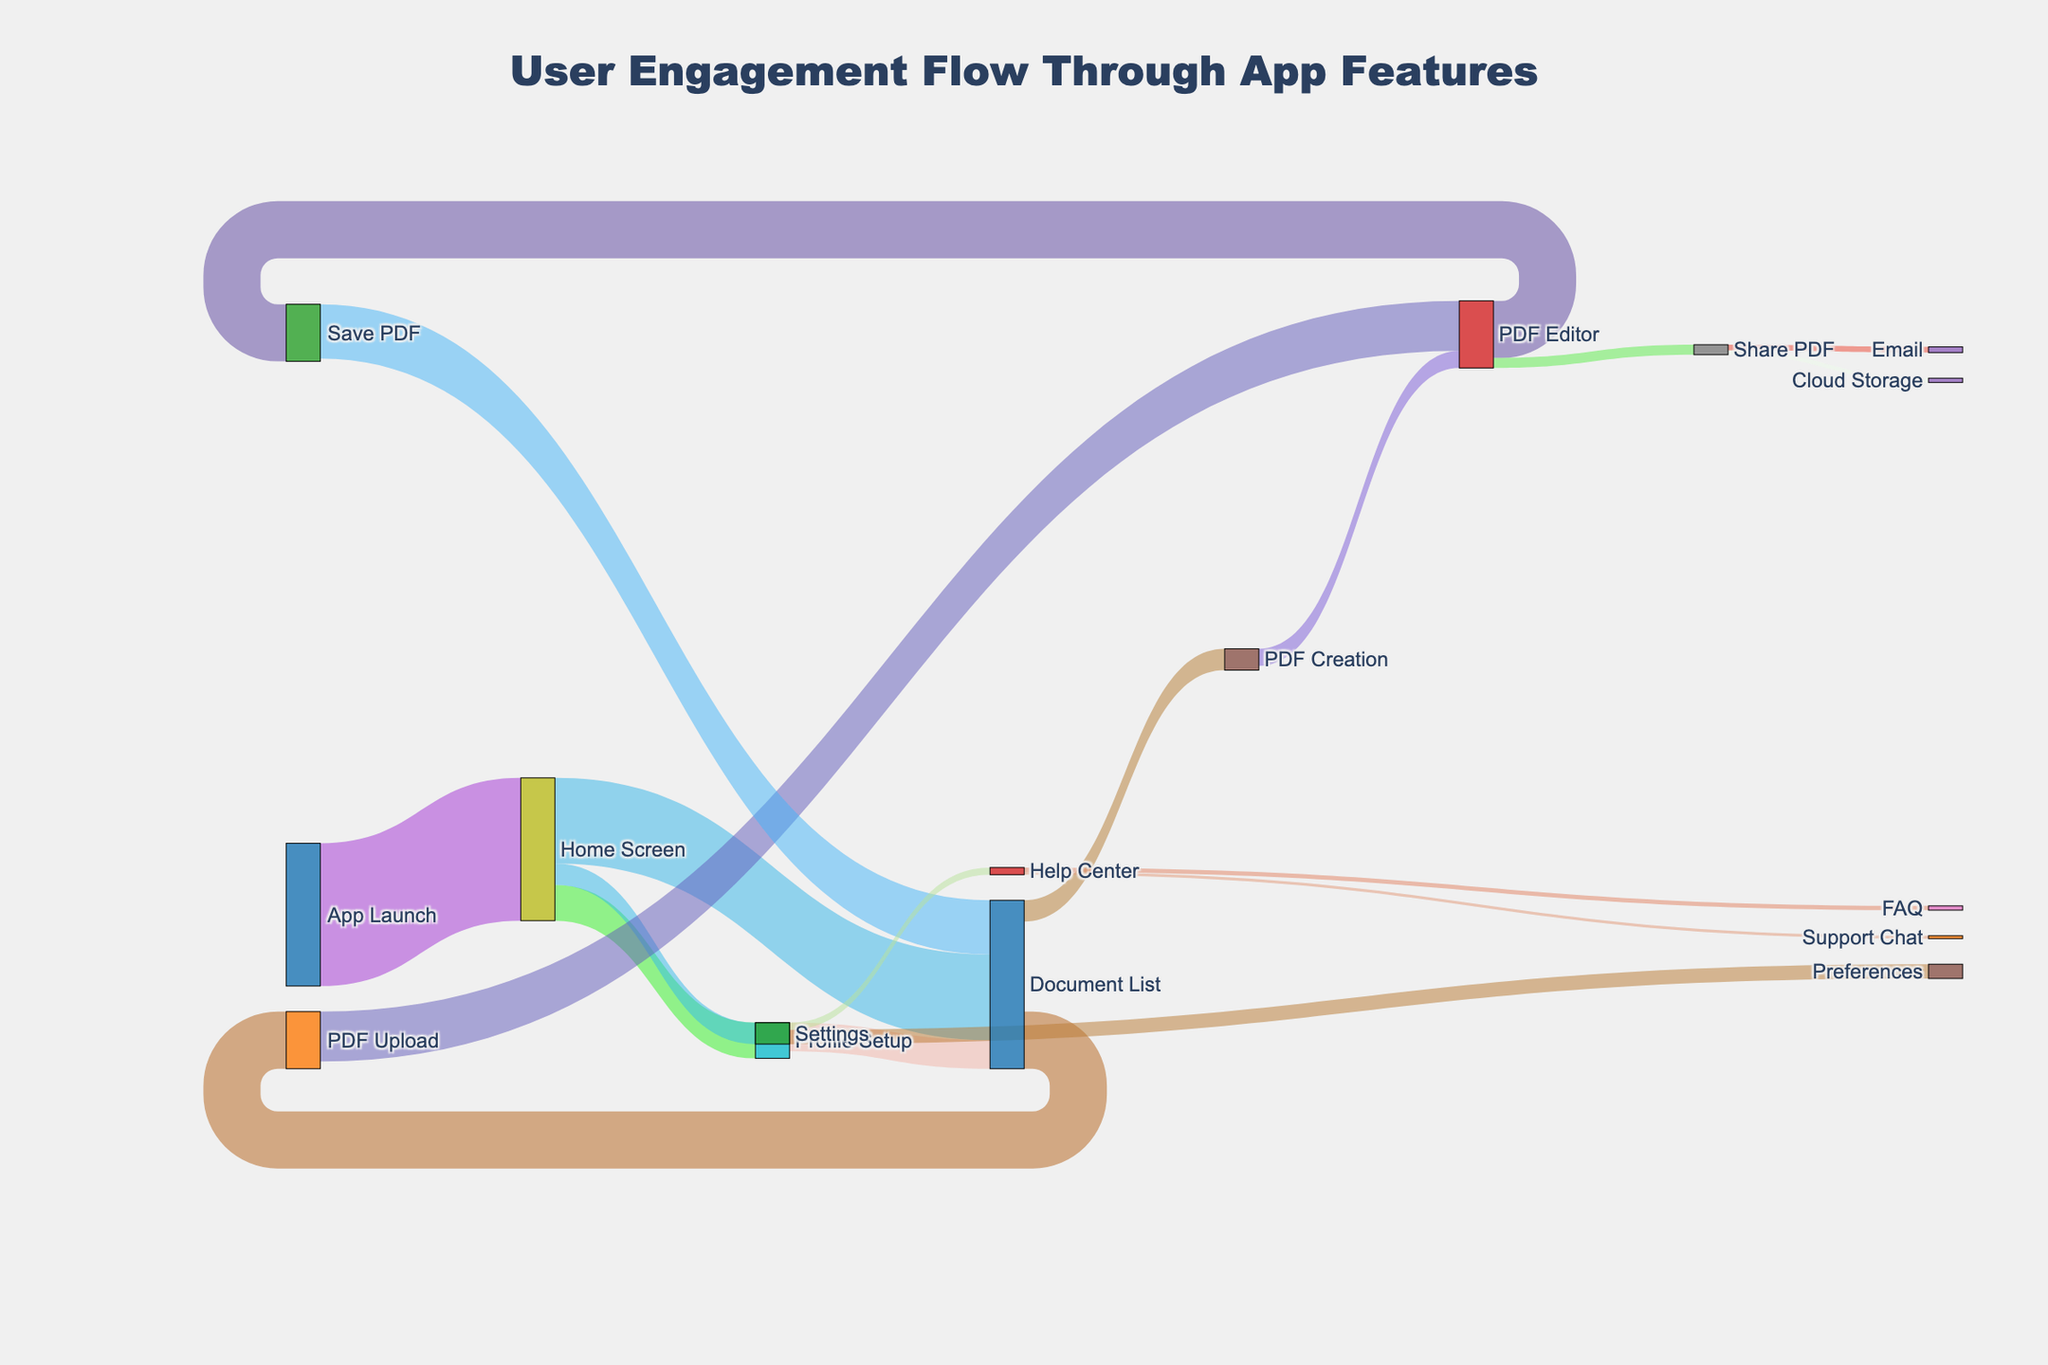What is the title of the Sankey Diagram? The title of the Sankey Diagram is located at the top-center of the figure. It is written in bold and larger font size to catch the viewer's attention. The specific text states the main topic of the diagram, which is "User Engagement Flow Through App Features".
Answer: User Engagement Flow Through App Features How many users go from the Home Screen to the Settings section? To find the number of users going from the Home Screen to Settings, look at the thickness of the flow between these two nodes. The numerical value representing this flow is provided along the path "Home Screen" to "Settings", which is 150.
Answer: 150 What is the total number of users that interact with the Document List after launching the app? First, identify the users who directly access the Document List from the Home Screen, which is 600 users. Then add the users who access the Document List via Profile Setup, 250 (Profile Setup) * 200/250 (going to Document List from Profile Setup). Total = 600 + 200 = 800.
Answer: 800 Which feature receives more users, PDF Upload or PDF Creation? Compare the values leading to PDF Upload and PDF Creation from the Document List. Document List to PDF Upload has a flow value of 400, while Document List to PDF Creation has a flow value of 150. Since 400 > 150, PDF Upload receives more users.
Answer: PDF Upload What proportion of users who reach the PDF Editor save their PDF? The total number of users reaching the PDF Editor is from both PDF Upload and PDF Creation, 350 (from PDF Upload) + 120 (from PDF Creation) = 470 users. Out of these, 400 save their PDF as indicated by the flow from PDF Editor to Save PDF. The proportion is 400/470.
Answer: 400/470 After settings, which feature is accessed most frequently? From the Settings, users can go to either Preferences or Help Center. Preferences receives 100 users, while Help Center gets 50 users. Therefore, Preferences is accessed most frequently.
Answer: Preferences How many users eventually come back to the Document List after saving their PDF? Users who save their PDF in the Save PDF feature then return to Document List. The flow value indicating this return is 380.
Answer: 380 Out of the users who visit the Help Center, how many proceed to the FAQ section? The Help Center has two subsequent flows: to FAQ and Support Chat. From the flow values, 30 users move to FAQ out of the total 50 users who visit Help Center.
Answer: 30 Which flow path has the largest number of users? Examine all flow values in the Sankey Diagram and identify the largest one, which is the flow from App Launch to Home Screen with a value of 1000.
Answer: App Launch to Home Screen What percentage of users who upload a PDF eventually share it via email? First, identify the number of users who upload a PDF, which is 400. From these, the flow to Share PDF is 70 (combine those who share PDF via Email and Cloud Storage). Out of those who share PDF (70), 40 choose Email. Therefore, the percentage is (40 / 400) * 100%.
Answer: 10% 